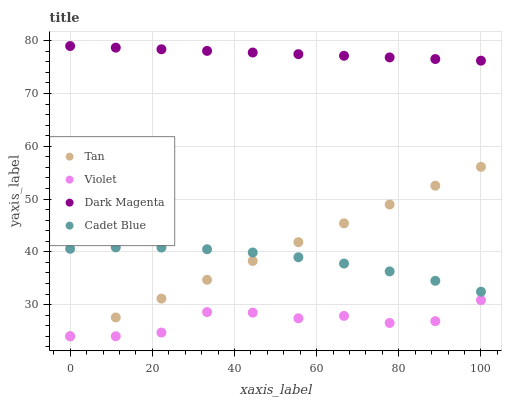Does Violet have the minimum area under the curve?
Answer yes or no. Yes. Does Dark Magenta have the maximum area under the curve?
Answer yes or no. Yes. Does Cadet Blue have the minimum area under the curve?
Answer yes or no. No. Does Cadet Blue have the maximum area under the curve?
Answer yes or no. No. Is Dark Magenta the smoothest?
Answer yes or no. Yes. Is Violet the roughest?
Answer yes or no. Yes. Is Cadet Blue the smoothest?
Answer yes or no. No. Is Cadet Blue the roughest?
Answer yes or no. No. Does Tan have the lowest value?
Answer yes or no. Yes. Does Cadet Blue have the lowest value?
Answer yes or no. No. Does Dark Magenta have the highest value?
Answer yes or no. Yes. Does Cadet Blue have the highest value?
Answer yes or no. No. Is Cadet Blue less than Dark Magenta?
Answer yes or no. Yes. Is Dark Magenta greater than Cadet Blue?
Answer yes or no. Yes. Does Tan intersect Cadet Blue?
Answer yes or no. Yes. Is Tan less than Cadet Blue?
Answer yes or no. No. Is Tan greater than Cadet Blue?
Answer yes or no. No. Does Cadet Blue intersect Dark Magenta?
Answer yes or no. No. 